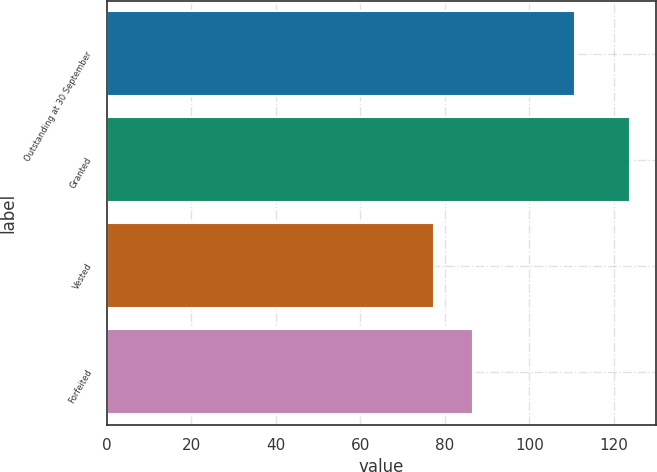<chart> <loc_0><loc_0><loc_500><loc_500><bar_chart><fcel>Outstanding at 30 September<fcel>Granted<fcel>Vested<fcel>Forfeited<nl><fcel>110.75<fcel>123.77<fcel>77.33<fcel>86.61<nl></chart> 